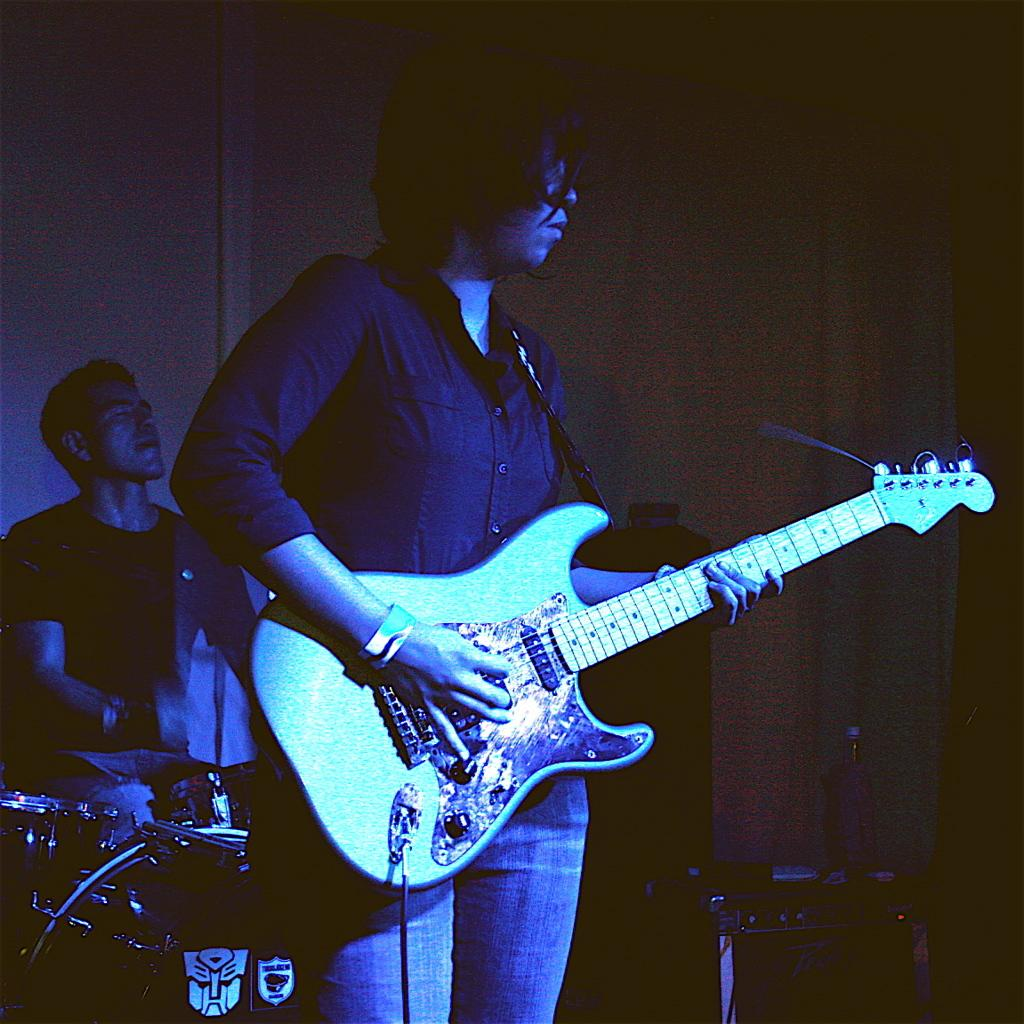What are the two people in the image doing? There is a person playing a guitar and another person playing drums in the image. What type of instruments are being played in the image? The guitar and drums are the instruments being played in the image. What type of care do the boys in the image need? There is no mention of boys in the image; it features two people playing instruments. 